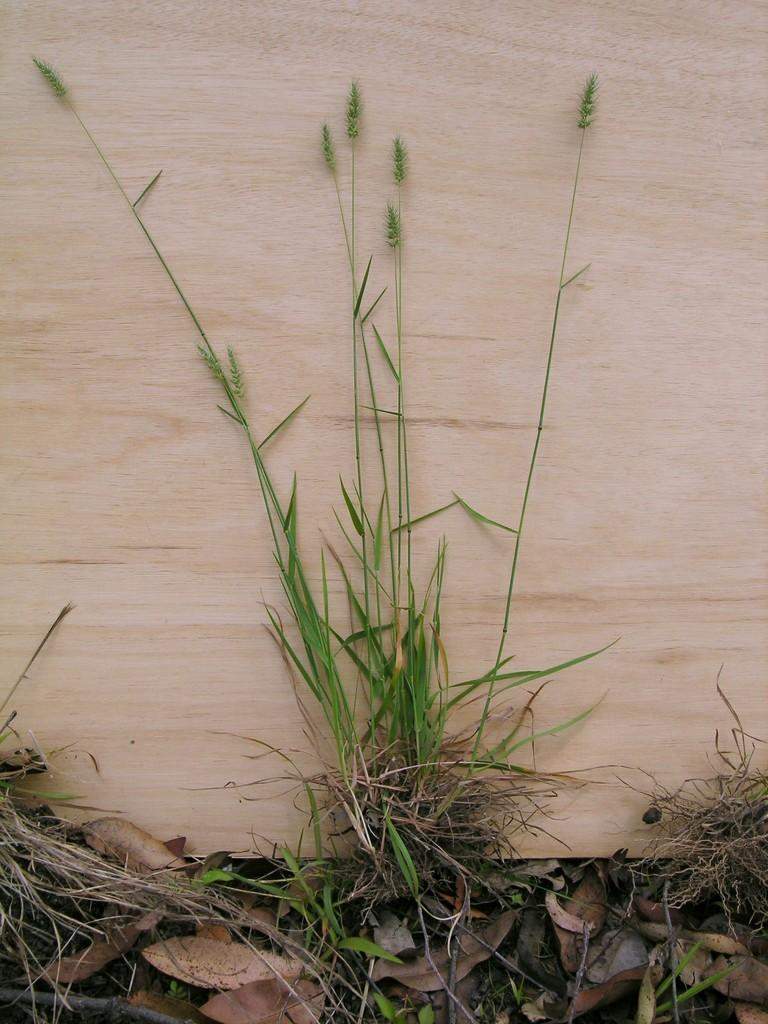What type of living organisms can be seen in the image? Plants can be seen in the image. What material is the wooden object made of? The wooden object is made of wood. What type of behavior can be observed in the plants in the image? There is no behavior to observe in the plants, as they are stationary and not capable of exhibiting behavior. 